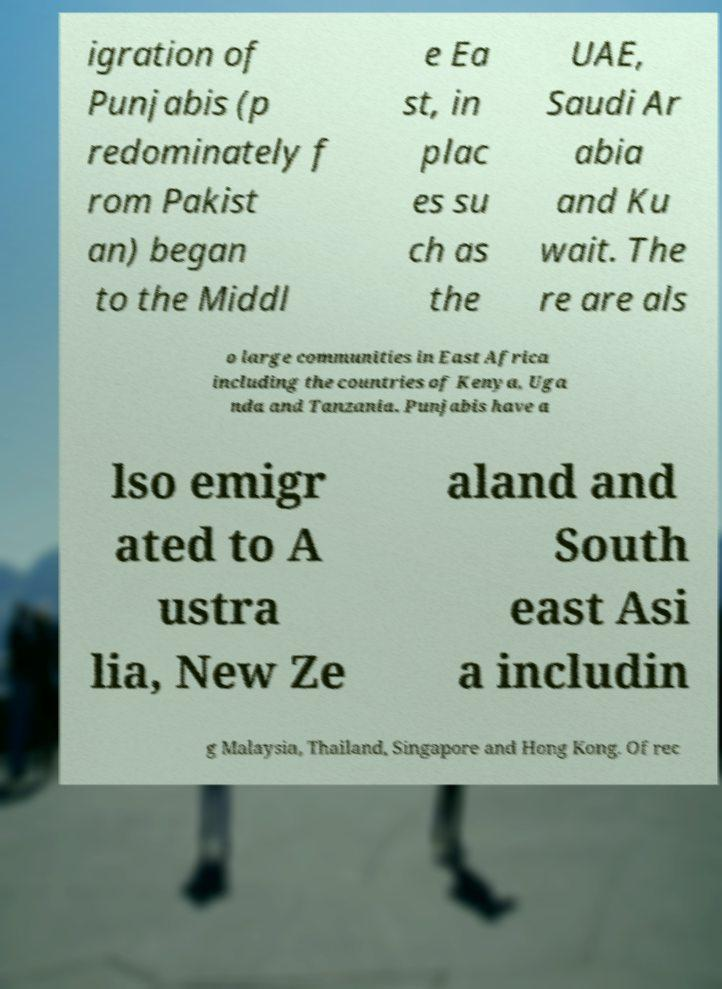Could you assist in decoding the text presented in this image and type it out clearly? igration of Punjabis (p redominately f rom Pakist an) began to the Middl e Ea st, in plac es su ch as the UAE, Saudi Ar abia and Ku wait. The re are als o large communities in East Africa including the countries of Kenya, Uga nda and Tanzania. Punjabis have a lso emigr ated to A ustra lia, New Ze aland and South east Asi a includin g Malaysia, Thailand, Singapore and Hong Kong. Of rec 